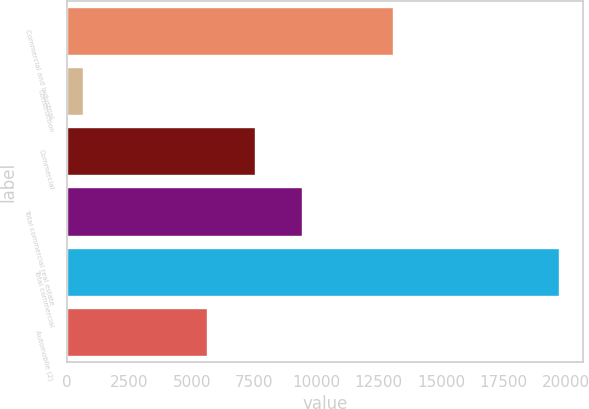Convert chart to OTSL. <chart><loc_0><loc_0><loc_500><loc_500><bar_chart><fcel>Commercial and industrial<fcel>Construction<fcel>Commercial<fcel>Total commercial real estate<fcel>Total commercial<fcel>Automobile (2)<nl><fcel>13063<fcel>650<fcel>7520.4<fcel>9426.8<fcel>19714<fcel>5614<nl></chart> 